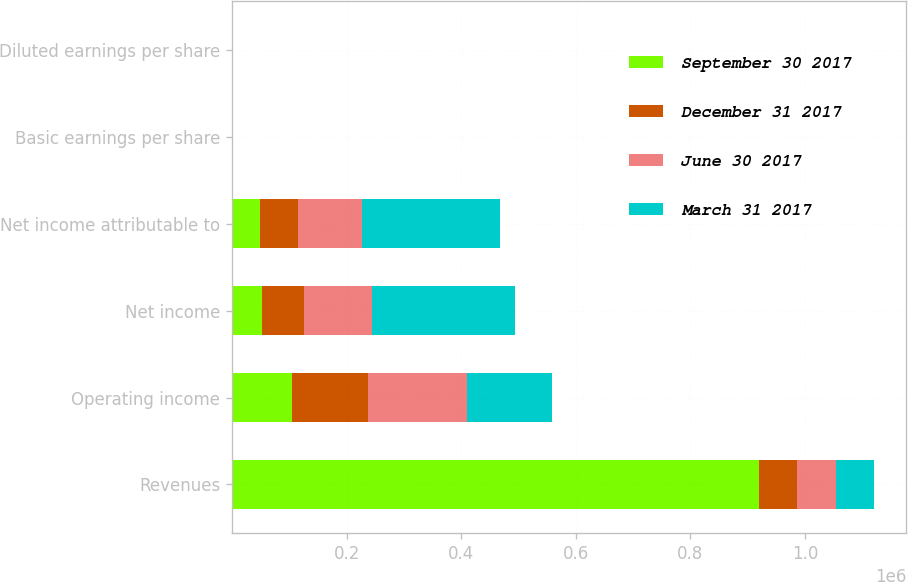Convert chart. <chart><loc_0><loc_0><loc_500><loc_500><stacked_bar_chart><ecel><fcel>Revenues<fcel>Operating income<fcel>Net income<fcel>Net income attributable to<fcel>Basic earnings per share<fcel>Diluted earnings per share<nl><fcel>September 30 2017<fcel>919762<fcel>104970<fcel>52959<fcel>48813<fcel>0.32<fcel>0.32<nl><fcel>December 31 2017<fcel>66909<fcel>131852<fcel>72443<fcel>66909<fcel>0.44<fcel>0.44<nl><fcel>June 30 2017<fcel>66909<fcel>172471<fcel>118362<fcel>110740<fcel>0.72<fcel>0.71<nl><fcel>March 31 2017<fcel>66909<fcel>149575<fcel>250305<fcel>241962<fcel>1.52<fcel>1.51<nl></chart> 